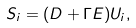<formula> <loc_0><loc_0><loc_500><loc_500>S _ { i } = ( D + \Gamma E ) U _ { i } ,</formula> 